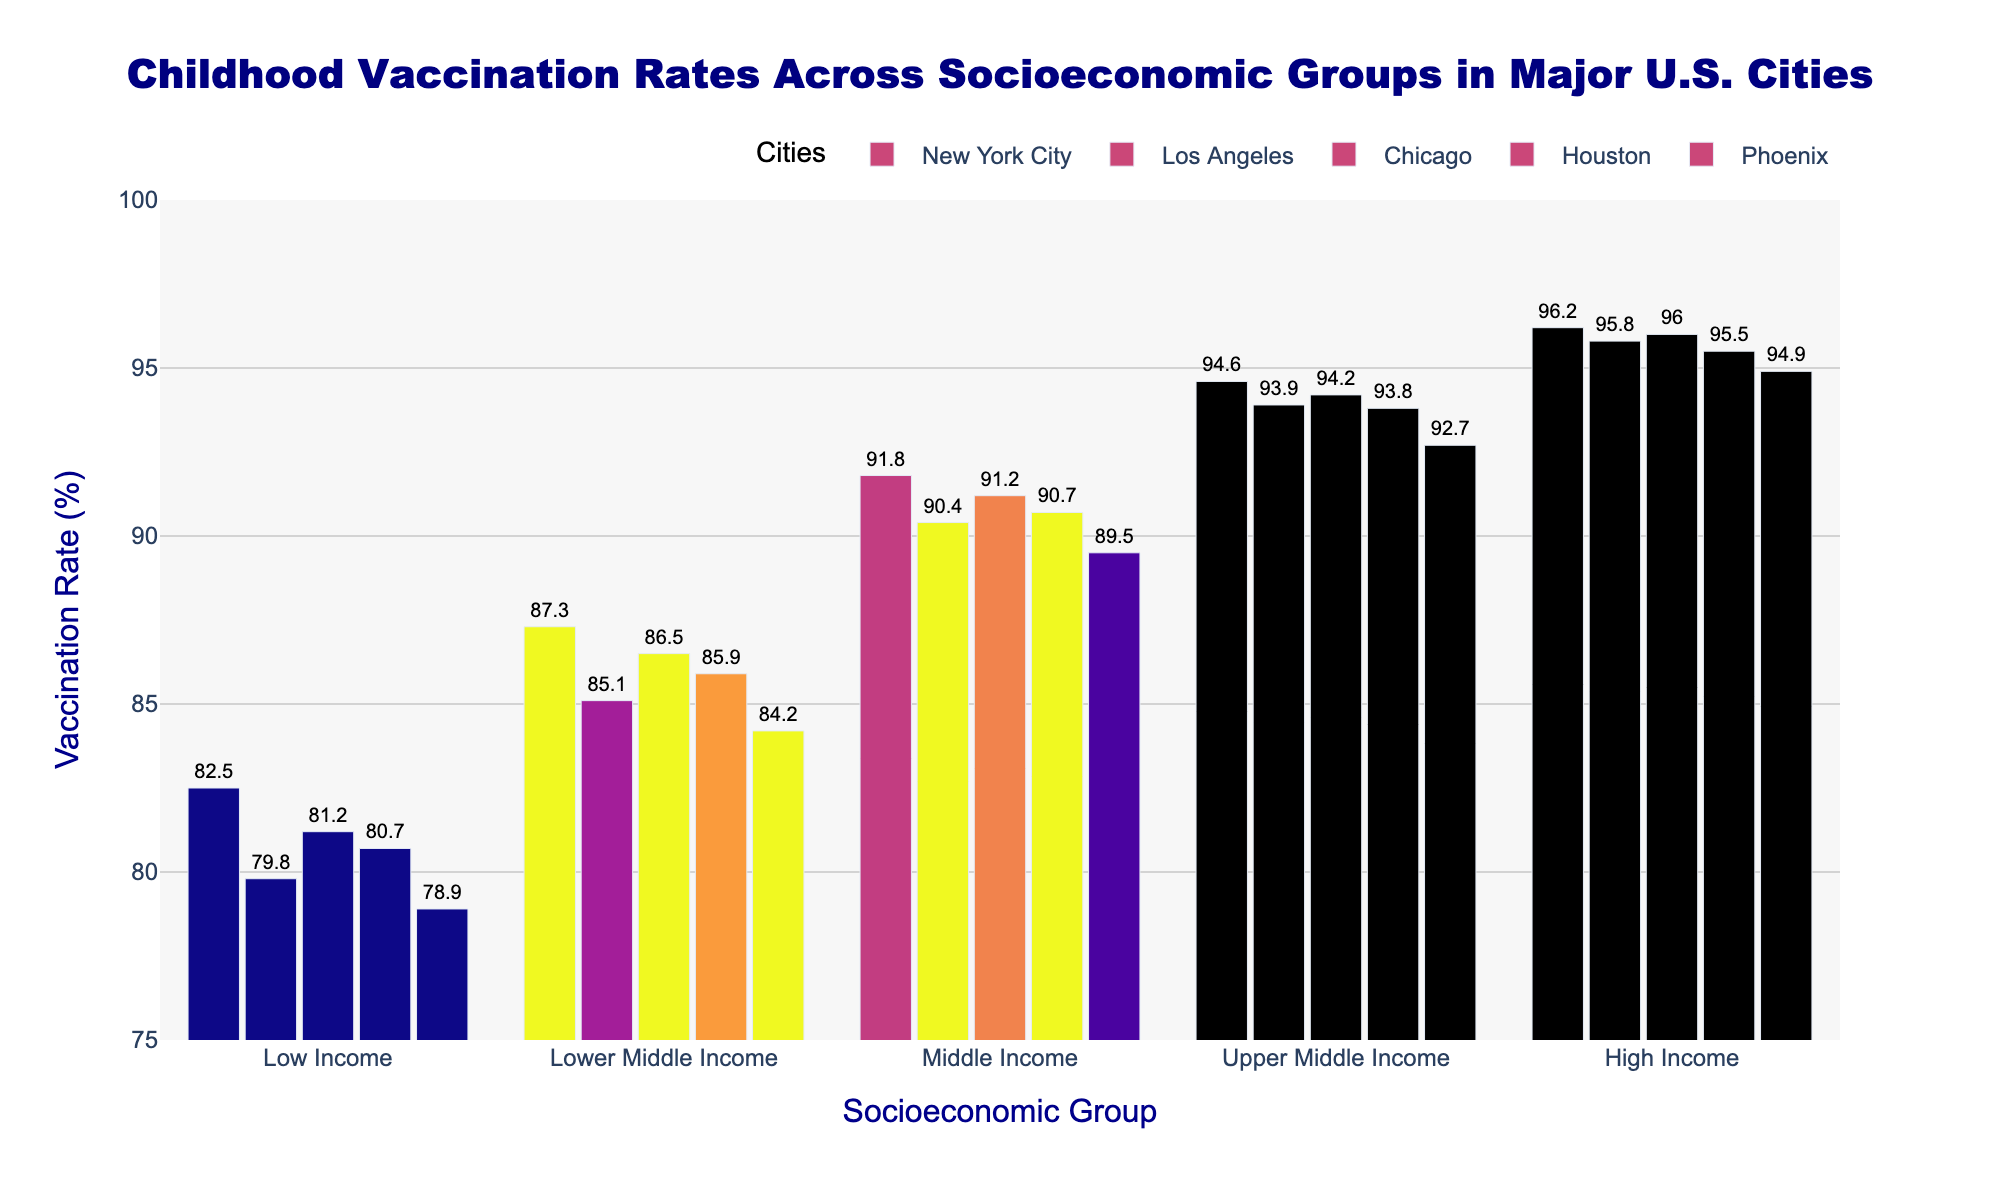What city has the highest vaccination rate in the Low Income group? Look at the bar representing the Low Income group and compare the heights of the bars for each city. The highest bar in this group corresponds to New York City.
Answer: New York City Which socioeconomic group has the lowest vaccination rate in Phoenix? Identify the bars for each socioeconomic group specific to Phoenix and compare their heights. The "Low Income" group has the shortest bar, indicating the lowest vaccination rate.
Answer: Low Income By how much does the vaccination rate of the High Income group in New York City exceed that of the Lower Middle Income group in Houston? First, note the vaccination rate for the High Income group in New York City, which is 96.2. Then, find the rate for the Lower Middle Income group in Houston, which is 85.9. Calculate the difference: 96.2 - 85.9 = 10.3.
Answer: 10.3 What is the average vaccination rate for the Middle Income group across all cities? Sum the vaccination rates for the Middle Income group across New York City (91.8), Los Angeles (90.4), Chicago (91.2), Houston (90.7), and Phoenix (89.5). Calculate the average by dividing the sum by 5. The sum is 453.6, and the average is 453.6 / 5 = 90.72.
Answer: 90.72 Which city has the smallest gap between its High Income and Low Income vaccination rates? Calculate the differences between the High Income and Low Income vaccination rates for each city: New York City (96.2 - 82.5 = 13.7), Los Angeles (95.8 - 79.8 = 16.0), Chicago (96.0 - 81.2 = 14.8), Houston (95.5 - 80.7 = 14.8), and Phoenix (94.9 - 78.9 = 16.0). The smallest gap is 13.7 in New York City.
Answer: New York City Does the Upper Middle Income group have higher vaccination rates in all cities compared to the Lower Middle Income group? Compare the bar heights for the Upper Middle Income group and the Lower Middle Income group for each city. For New York City (94.6 > 87.3), Los Angeles (93.9 > 85.1), Chicago (94.2 > 86.5), Houston (93.8 > 85.9), and Phoenix (92.7 > 84.2), the Upper Middle Income group always has higher rates.
Answer: Yes Do any of the cities have a vaccination rate above 95% in three or more socioeconomic groups? Identify the socioeconomic groups with vaccination rates above 95% for each city. New York City (High Income: 96.2, Upper Middle Income: 94.6, Middle Income: 91.8) and Los Angeles (High Income: 95.8, Upper Middle Income: 93.9, Middle Income: 90.4) both have fewer than three groups above 95%. Hence, no city meets the criteria.
Answer: No What is the average vaccination rate for Phoenix across all socioeconomic groups? Find the vaccination rates for each socioeconomic group in Phoenix: Low Income (78.9), Lower Middle Income (84.2), Middle Income (89.5), Upper Middle Income (92.7), and High Income (94.9). Sum these rates: 78.9 + 84.2 + 89.5 + 92.7 + 94.9 = 440.2. Calculate the average: 440.2 / 5 = 88.04.
Answer: 88.04 Is the vaccination rate for the Upper Middle Income group in Houston higher than the Middle Income group in Los Angeles? Compare the bars for these groups: the Upper Middle Income group in Houston has a rate of 93.8, while the Middle Income group in Los Angeles has a rate of 90.4. Since 93.8 > 90.4, the rate is higher in Houston.
Answer: Yes 